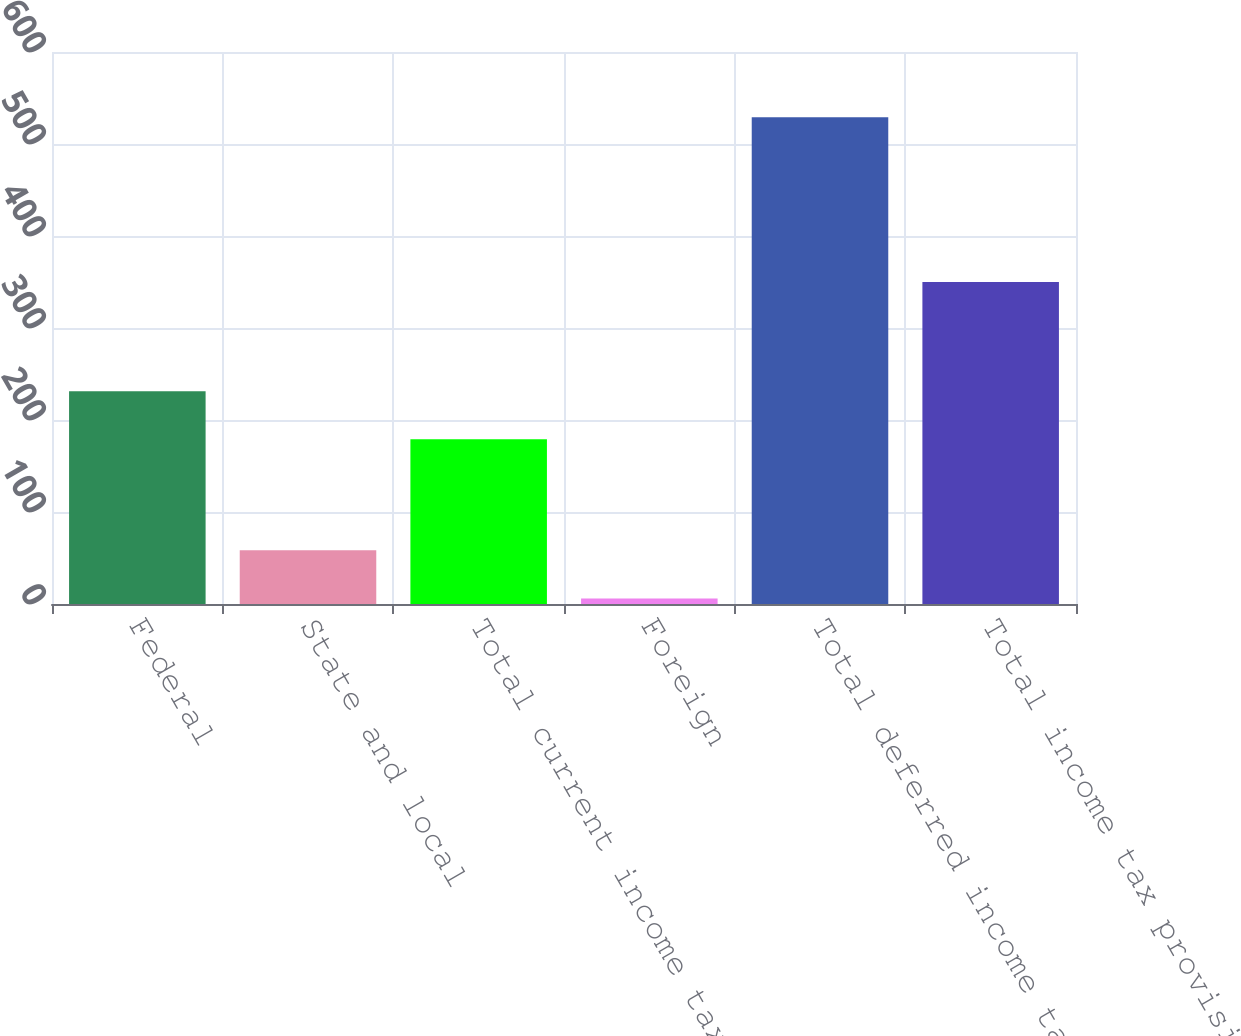Convert chart. <chart><loc_0><loc_0><loc_500><loc_500><bar_chart><fcel>Federal<fcel>State and local<fcel>Total current income tax<fcel>Foreign<fcel>Total deferred income tax<fcel>Total income tax provision<nl><fcel>231.3<fcel>58.3<fcel>179<fcel>6<fcel>529<fcel>350<nl></chart> 